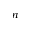Convert formula to latex. <formula><loc_0><loc_0><loc_500><loc_500>n</formula> 